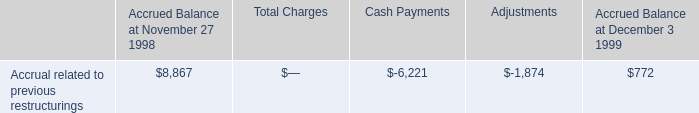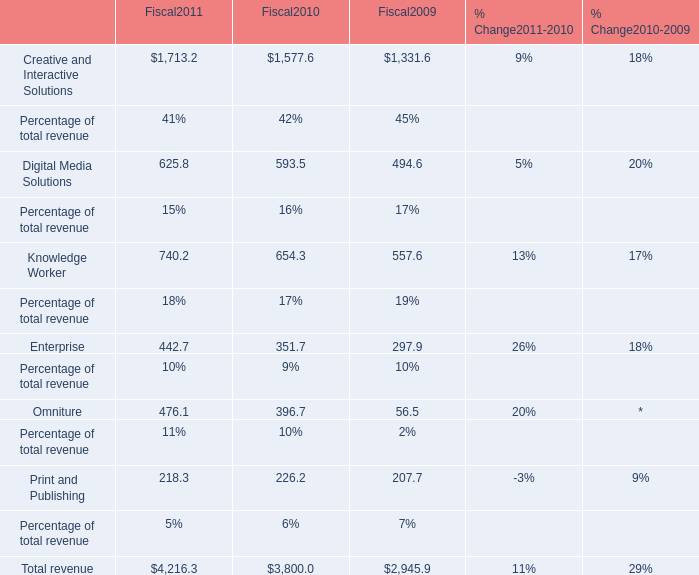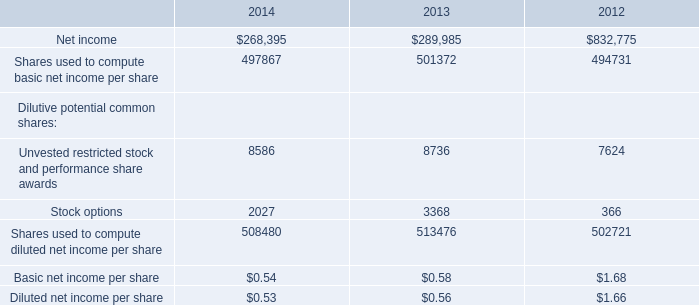what portion of the 1999 accrual balance related to restructurings is comprised of canceled contracts? 
Computations: (0.4 / 0.8)
Answer: 0.5. 